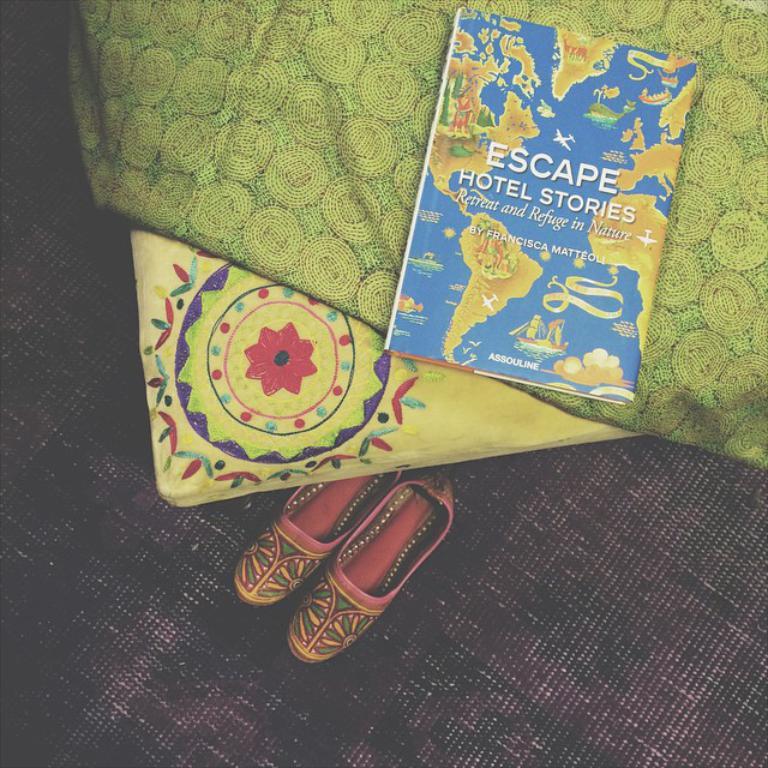What is that book called?
Provide a short and direct response. Escape hotel stories. Who wrote this book?
Offer a terse response. Francisca matteoli. 